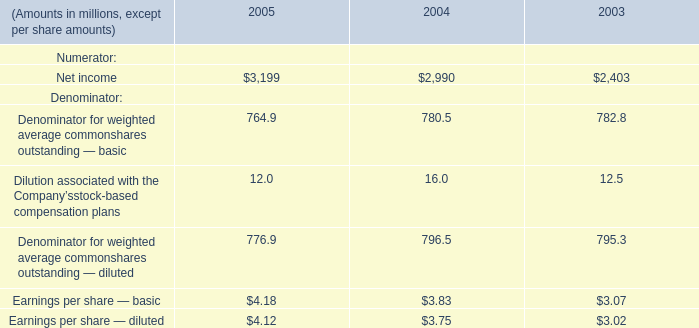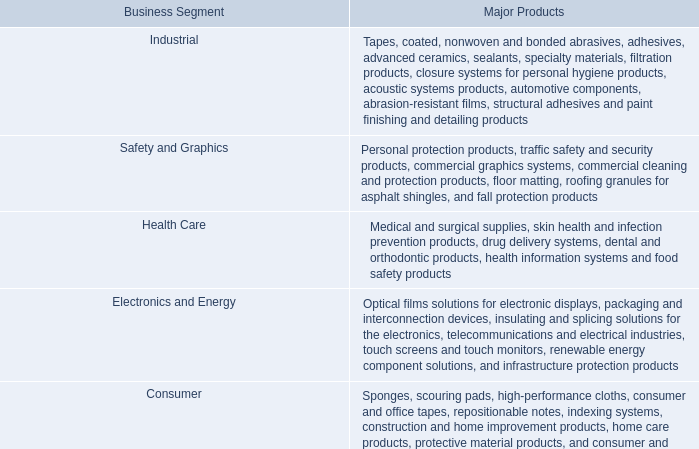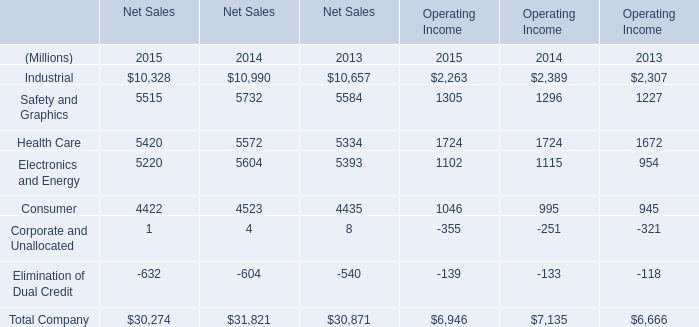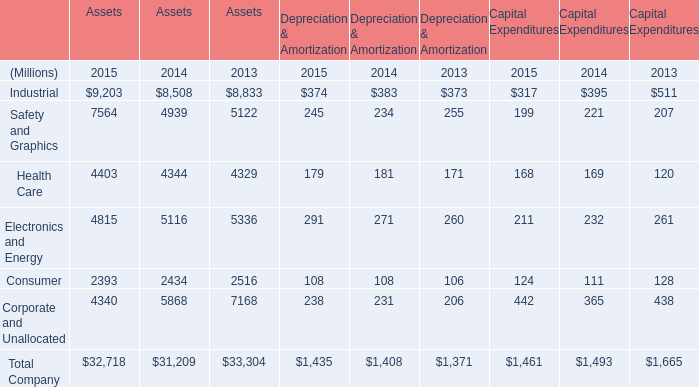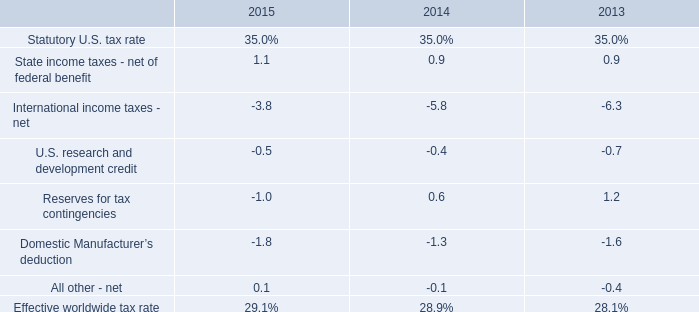What is the total amount of Net income of 2004, and Electronics and Energy of Assets 2014 ? 
Computations: (2990.0 + 5116.0)
Answer: 8106.0. 